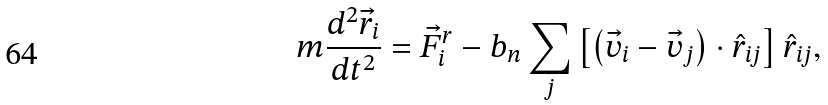<formula> <loc_0><loc_0><loc_500><loc_500>m \frac { d ^ { 2 } { \vec { r } } _ { i } } { d t ^ { 2 } } = { \vec { F } } ^ { r } _ { i } - b _ { n } \sum _ { j } \left [ \left ( { \vec { v } } _ { i } - { \vec { v } } _ { j } \right ) \cdot \hat { r } _ { i j } \right ] \hat { r } _ { i j } ,</formula> 